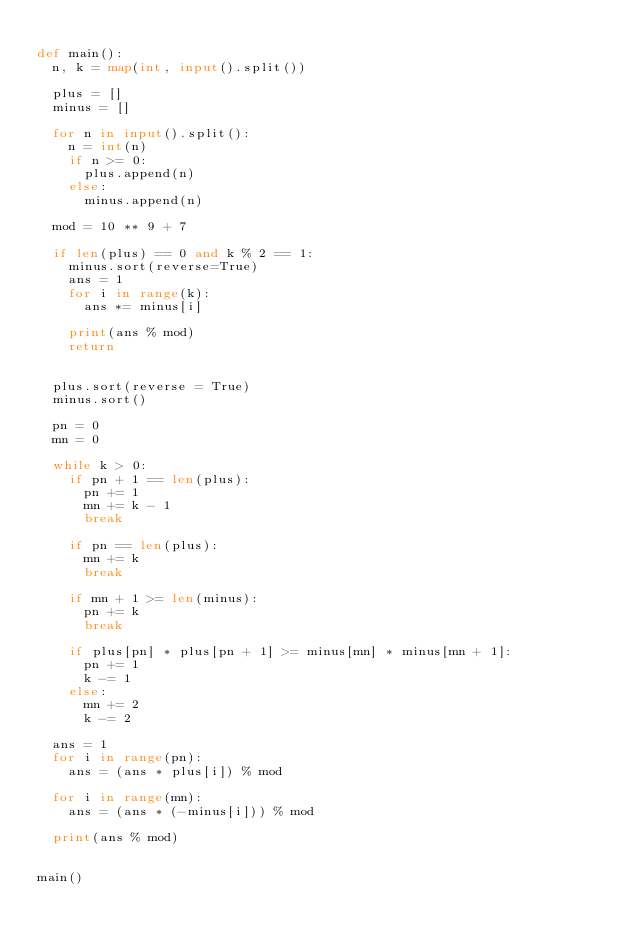<code> <loc_0><loc_0><loc_500><loc_500><_Python_>
def main():
  n, k = map(int, input().split())

  plus = []
  minus = []

  for n in input().split():
    n = int(n)
    if n >= 0:
      plus.append(n)
    else:
      minus.append(n)

  mod = 10 ** 9 + 7

  if len(plus) == 0 and k % 2 == 1:
    minus.sort(reverse=True)
    ans = 1
    for i in range(k):
      ans *= minus[i]

    print(ans % mod)
    return


  plus.sort(reverse = True)
  minus.sort()

  pn = 0
  mn = 0

  while k > 0:
    if pn + 1 == len(plus):
      pn += 1
      mn += k - 1
      break

    if pn == len(plus):
      mn += k
      break

    if mn + 1 >= len(minus):
      pn += k
      break

    if plus[pn] * plus[pn + 1] >= minus[mn] * minus[mn + 1]:
      pn += 1
      k -= 1
    else:
      mn += 2
      k -= 2

  ans = 1
  for i in range(pn):
    ans = (ans * plus[i]) % mod

  for i in range(mn):
    ans = (ans * (-minus[i])) % mod

  print(ans % mod)


main()
</code> 